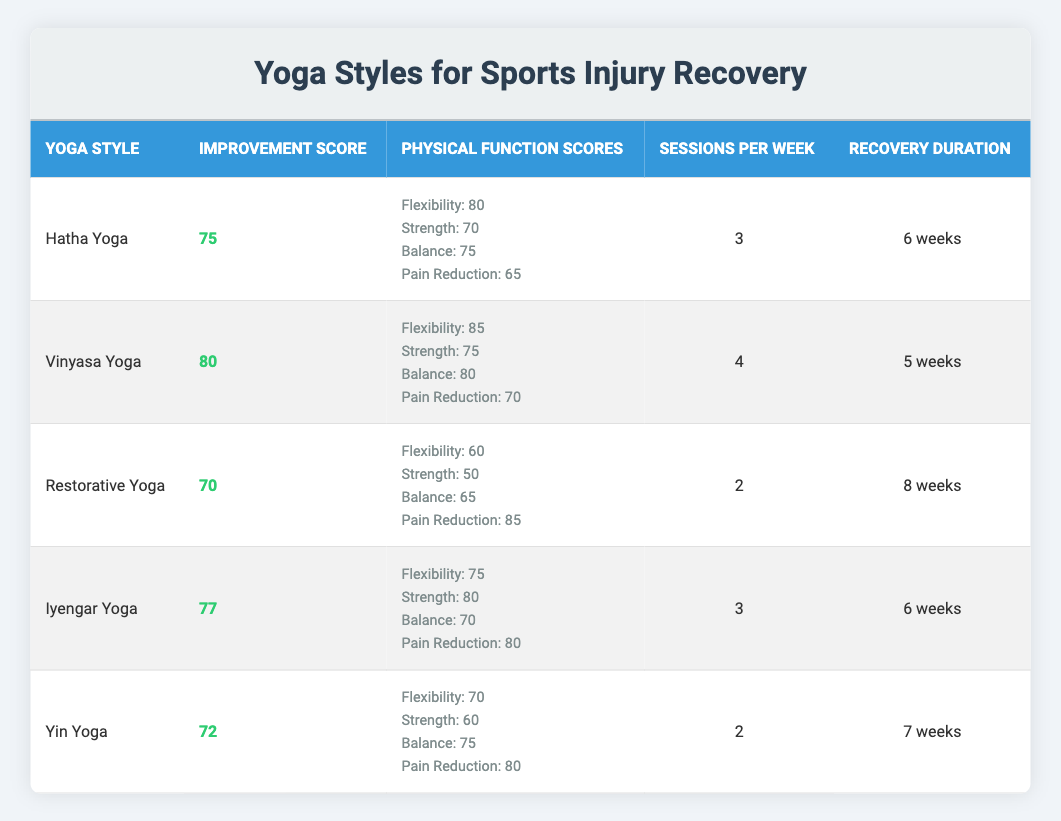What is the improvement score for Vinyasa Yoga? The table lists Vinyasa Yoga under the "Yoga Style" column, and its corresponding "Improvement Score" is indicated in the second column. Directly from the table, the improvement score for Vinyasa Yoga is 80.
Answer: 80 Which yoga style has the highest pain reduction score? The "Pain Reduction" scores are listed within the "Physical Function Scores" column for each yoga style. Upon comparing the values, Restorative Yoga has the highest pain reduction score of 85.
Answer: Restorative Yoga What is the average recommended number of sessions per week for all yoga styles? To find the average, we sum the recommended sessions for all yoga styles (3 + 4 + 2 + 3 + 2 = 14) and then divide by the number of styles, which is 5. Thus, the average is 14 divided by 5 equals 2.8.
Answer: 2.8 Is Yin Yoga more effective than Hatha Yoga based on the improvement score? Yin Yoga has an improvement score of 72 while Hatha Yoga scores 75. Since 72 is less than 75, this indicates that Yin Yoga is not more effective than Hatha Yoga.
Answer: No How many total weeks are needed for the recovery duration across the recommended yoga styles? The recovery durations are listed for each style: 6, 5, 8, 6, and 7 weeks. Adding these together (6 + 5 + 8 + 6 + 7 = 32) gives a total recovery duration of 32 weeks across all styles.
Answer: 32 weeks Which style has the lowest strength score and what is the score? By checking the "Strength" scores among all styles, Restorative Yoga has the lowest strength score of 50.
Answer: Restorative Yoga, 50 Which two yoga styles require the same number of sessions per week? Looking at the "Sessions per Week" column, Hatha Yoga and Iyengar Yoga both require 3 sessions per week. This means these two styles have the same requirement.
Answer: Hatha Yoga and Iyengar Yoga What is the duration difference between the longest and shortest recovery times among the yoga styles? The longest recovery duration is 8 weeks for Restorative Yoga and the shortest is 5 weeks for Vinyasa Yoga. The difference in duration is 8 - 5 = 3 weeks.
Answer: 3 weeks 